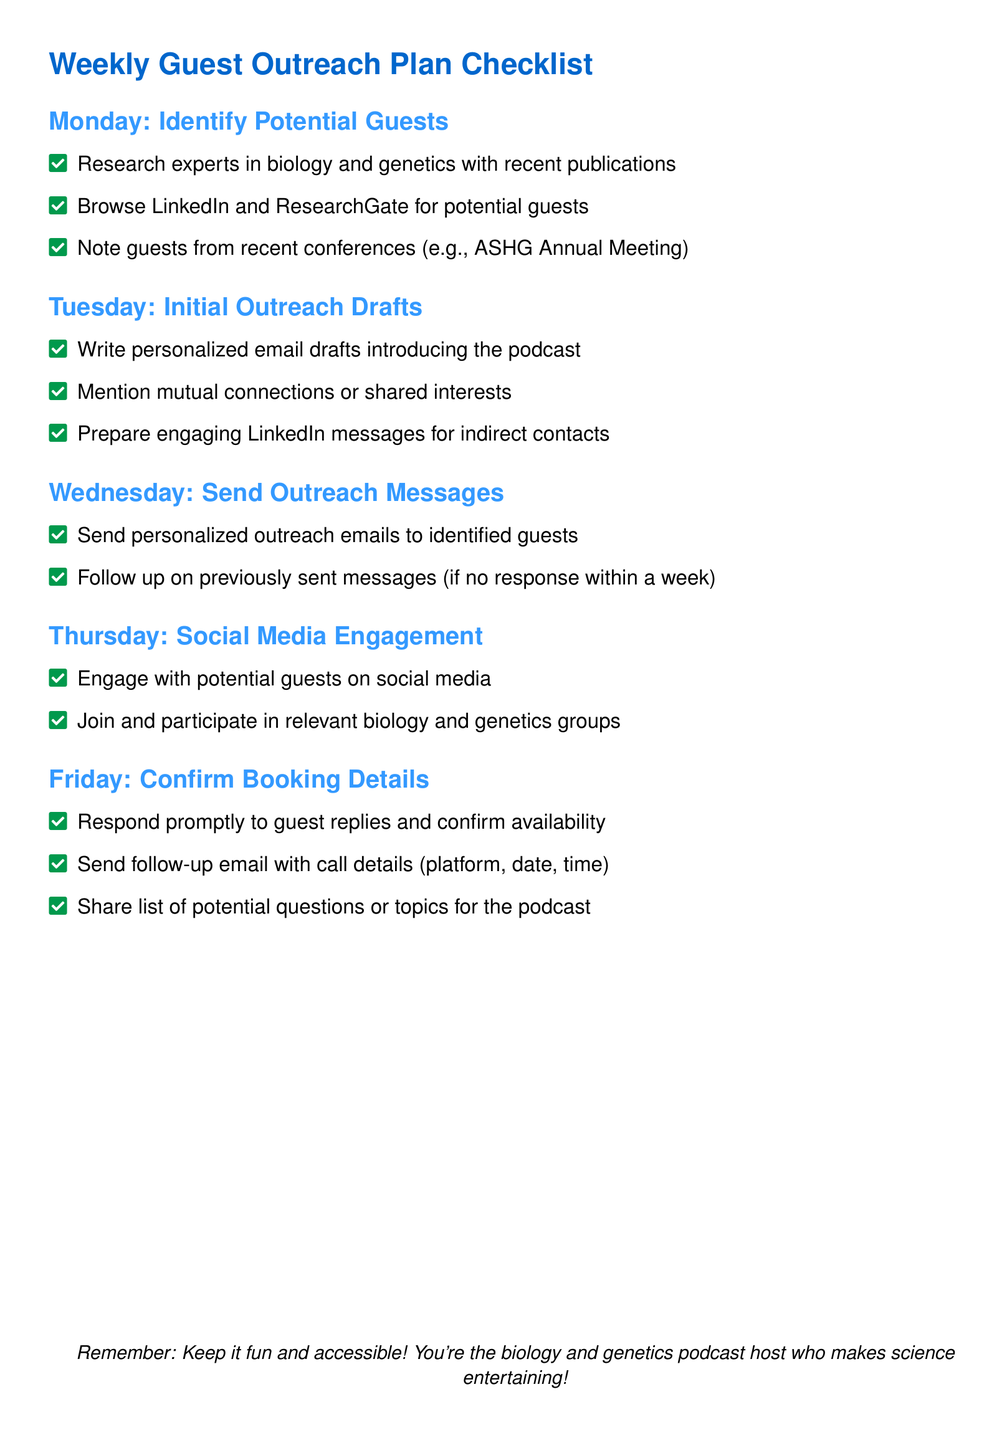What is the focus area for potential guests? The document specifies that potential guests should be experts in biology and genetics.
Answer: biology and genetics What day are outreach drafts written? The document states that initial outreach drafts are written on Tuesday.
Answer: Tuesday What should you do on Thursday regarding social media? The document mentions engaging with potential guests on social media and participating in relevant groups.
Answer: Engage with potential guests How many items are listed under Monday's tasks? There are three tasks listed under Monday's section in the document.
Answer: 3 What details are confirmed during Friday's tasks? The document indicates that booking details, such as availability and call details, are confirmed on Friday.
Answer: booking details What should be prepared for indirect contacts? Engaging LinkedIn messages are prepared for indirect contacts during the outreach process.
Answer: LinkedIn messages When do you follow up on previously sent messages? The document states to follow up if there is no response within a week.
Answer: within a week What type of connections should be mentioned in outreach emails? The document suggests mentioning mutual connections or shared interests in outreach emails.
Answer: mutual connections 